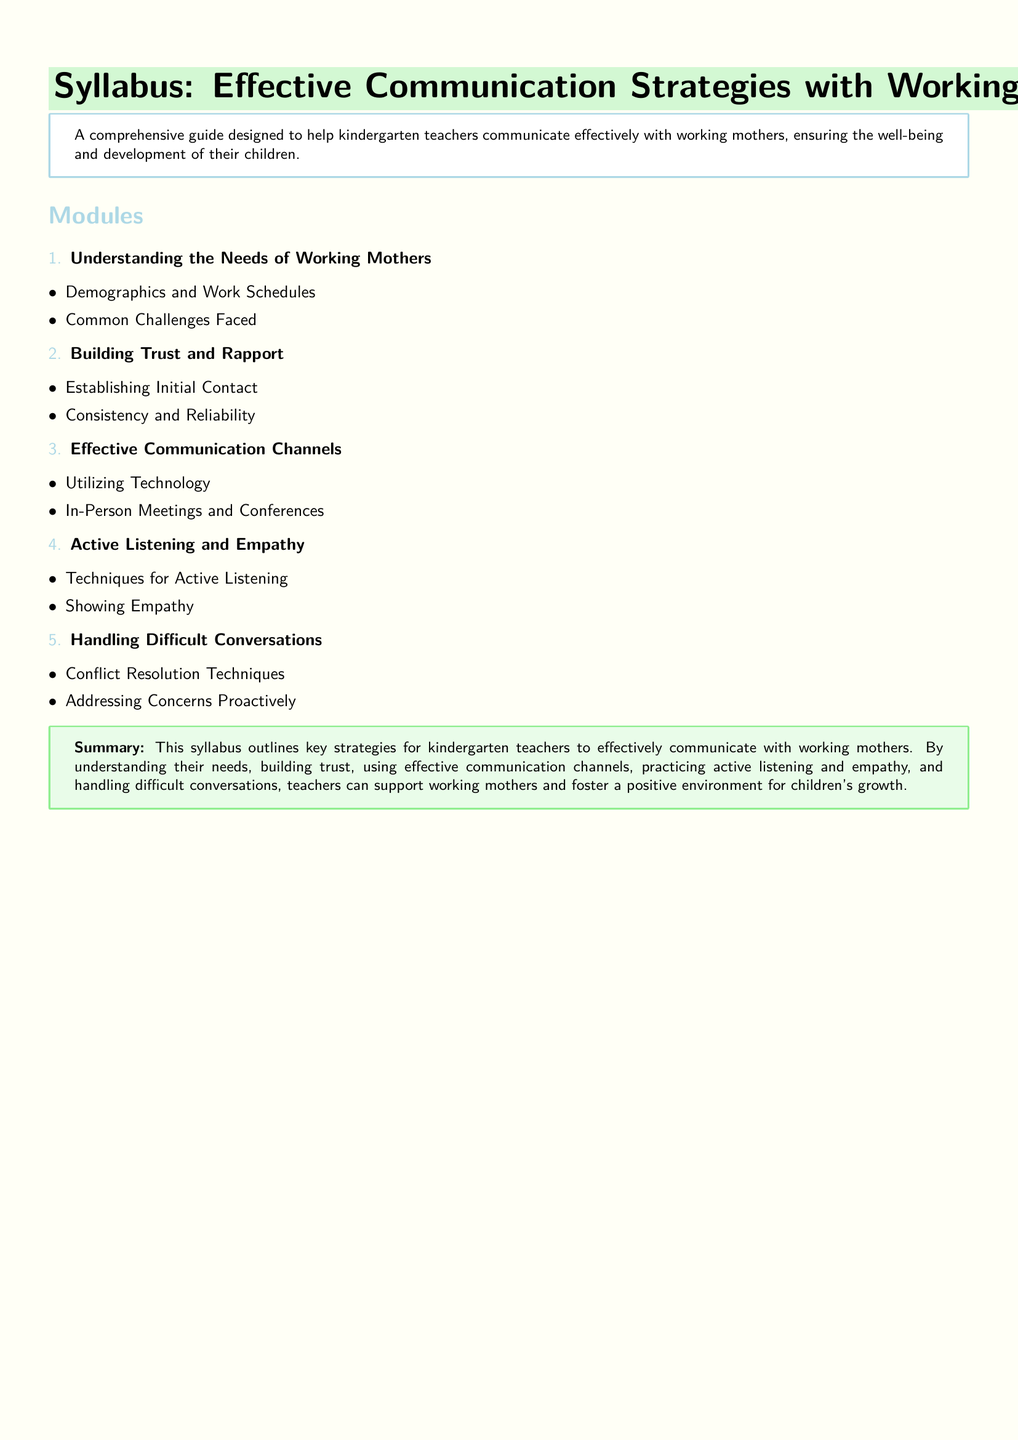What is the title of the syllabus? The title is presented prominently at the top of the document, indicating the subject of the syllabus.
Answer: Effective Communication Strategies with Working Mothers How many modules are included in the syllabus? The number of modules is found in the enumeration list within the syllabus.
Answer: 5 What is the first module about? The first module is listed at the beginning of the modules section and describes key topics.
Answer: Understanding the Needs of Working Mothers Which color is used for the main heading? The color of the main heading can be noted from the formatting in the document.
Answer: Pastel Green What technique is emphasized in the fourth module? The fourth module focuses on specific skills related to communication, as indicated in the module description.
Answer: Active Listening and Empathy What does the syllabus aim to foster according to the summary? The summary of the document mentions the objective of the communication strategies discussed.
Answer: A positive environment for children's growth What is one example of a communication channel mentioned? An example of a communication channel is provided in the relevant module of the syllabus.
Answer: Utilizing Technology What are teachers encouraged to show according to the active listening module? This aspect is highlighted in the description of techniques for effective communication.
Answer: Empathy What is the purpose of the syllabus? The overview provides insight into the overall intent of the document.
Answer: Help kindergarten teachers communicate effectively with working mothers 